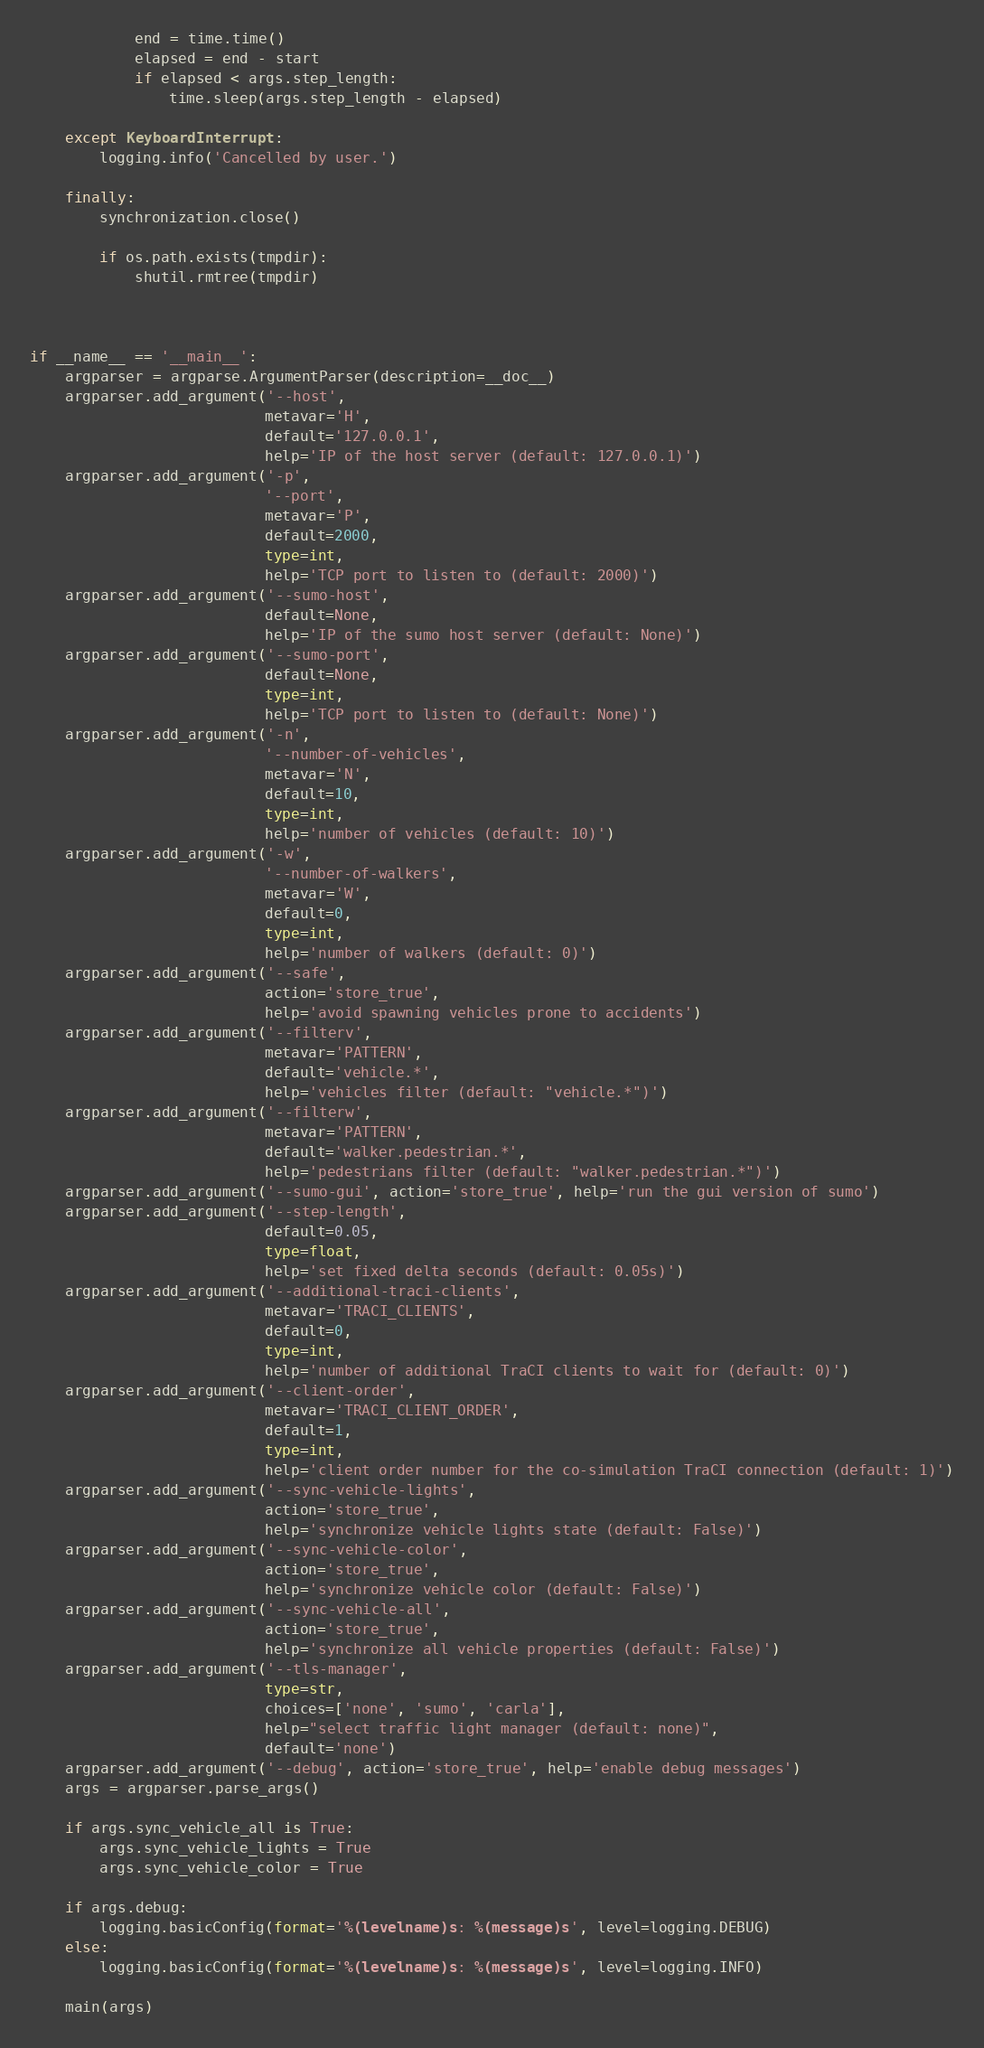Convert code to text. <code><loc_0><loc_0><loc_500><loc_500><_Python_>
            end = time.time()
            elapsed = end - start
            if elapsed < args.step_length:
                time.sleep(args.step_length - elapsed)

    except KeyboardInterrupt:
        logging.info('Cancelled by user.')

    finally:
        synchronization.close()

        if os.path.exists(tmpdir):
            shutil.rmtree(tmpdir)



if __name__ == '__main__':
    argparser = argparse.ArgumentParser(description=__doc__)
    argparser.add_argument('--host',
                           metavar='H',
                           default='127.0.0.1',
                           help='IP of the host server (default: 127.0.0.1)')
    argparser.add_argument('-p',
                           '--port',
                           metavar='P',
                           default=2000,
                           type=int,
                           help='TCP port to listen to (default: 2000)')
    argparser.add_argument('--sumo-host',
                           default=None,
                           help='IP of the sumo host server (default: None)')
    argparser.add_argument('--sumo-port',
                           default=None,
                           type=int,
                           help='TCP port to listen to (default: None)')
    argparser.add_argument('-n',
                           '--number-of-vehicles',
                           metavar='N',
                           default=10,
                           type=int,
                           help='number of vehicles (default: 10)')
    argparser.add_argument('-w',
                           '--number-of-walkers',
                           metavar='W',
                           default=0,
                           type=int,
                           help='number of walkers (default: 0)')
    argparser.add_argument('--safe',
                           action='store_true',
                           help='avoid spawning vehicles prone to accidents')
    argparser.add_argument('--filterv',
                           metavar='PATTERN',
                           default='vehicle.*',
                           help='vehicles filter (default: "vehicle.*")')
    argparser.add_argument('--filterw',
                           metavar='PATTERN',
                           default='walker.pedestrian.*',
                           help='pedestrians filter (default: "walker.pedestrian.*")')
    argparser.add_argument('--sumo-gui', action='store_true', help='run the gui version of sumo')
    argparser.add_argument('--step-length',
                           default=0.05,
                           type=float,
                           help='set fixed delta seconds (default: 0.05s)')
    argparser.add_argument('--additional-traci-clients',
                           metavar='TRACI_CLIENTS',
                           default=0,
                           type=int,
                           help='number of additional TraCI clients to wait for (default: 0)')
    argparser.add_argument('--client-order',
                           metavar='TRACI_CLIENT_ORDER',
                           default=1,
                           type=int,
                           help='client order number for the co-simulation TraCI connection (default: 1)')
    argparser.add_argument('--sync-vehicle-lights',
                           action='store_true',
                           help='synchronize vehicle lights state (default: False)')
    argparser.add_argument('--sync-vehicle-color',
                           action='store_true',
                           help='synchronize vehicle color (default: False)')
    argparser.add_argument('--sync-vehicle-all',
                           action='store_true',
                           help='synchronize all vehicle properties (default: False)')
    argparser.add_argument('--tls-manager',
                           type=str,
                           choices=['none', 'sumo', 'carla'],
                           help="select traffic light manager (default: none)",
                           default='none')
    argparser.add_argument('--debug', action='store_true', help='enable debug messages')
    args = argparser.parse_args()

    if args.sync_vehicle_all is True:
        args.sync_vehicle_lights = True
        args.sync_vehicle_color = True

    if args.debug:
        logging.basicConfig(format='%(levelname)s: %(message)s', level=logging.DEBUG)
    else:
        logging.basicConfig(format='%(levelname)s: %(message)s', level=logging.INFO)

    main(args)
</code> 